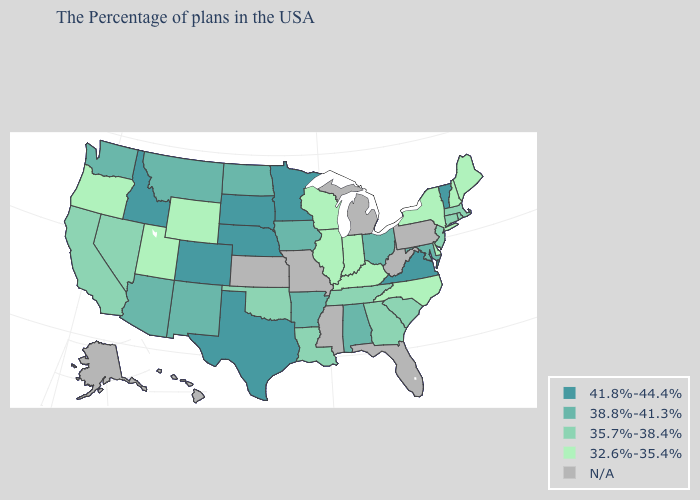What is the value of Mississippi?
Short answer required. N/A. Name the states that have a value in the range 32.6%-35.4%?
Concise answer only. Maine, New Hampshire, New York, Delaware, North Carolina, Kentucky, Indiana, Wisconsin, Illinois, Wyoming, Utah, Oregon. Which states have the highest value in the USA?
Keep it brief. Vermont, Virginia, Minnesota, Nebraska, Texas, South Dakota, Colorado, Idaho. Name the states that have a value in the range N/A?
Give a very brief answer. Pennsylvania, West Virginia, Florida, Michigan, Mississippi, Missouri, Kansas, Alaska, Hawaii. What is the value of Montana?
Quick response, please. 38.8%-41.3%. What is the lowest value in the USA?
Give a very brief answer. 32.6%-35.4%. Name the states that have a value in the range 35.7%-38.4%?
Quick response, please. Massachusetts, Rhode Island, Connecticut, New Jersey, South Carolina, Georgia, Tennessee, Louisiana, Oklahoma, Nevada, California. Name the states that have a value in the range 41.8%-44.4%?
Quick response, please. Vermont, Virginia, Minnesota, Nebraska, Texas, South Dakota, Colorado, Idaho. Among the states that border Maryland , does Virginia have the lowest value?
Be succinct. No. Name the states that have a value in the range N/A?
Write a very short answer. Pennsylvania, West Virginia, Florida, Michigan, Mississippi, Missouri, Kansas, Alaska, Hawaii. What is the value of Missouri?
Answer briefly. N/A. Does Vermont have the highest value in the USA?
Give a very brief answer. Yes. Name the states that have a value in the range 35.7%-38.4%?
Give a very brief answer. Massachusetts, Rhode Island, Connecticut, New Jersey, South Carolina, Georgia, Tennessee, Louisiana, Oklahoma, Nevada, California. Name the states that have a value in the range 35.7%-38.4%?
Write a very short answer. Massachusetts, Rhode Island, Connecticut, New Jersey, South Carolina, Georgia, Tennessee, Louisiana, Oklahoma, Nevada, California. Does the map have missing data?
Concise answer only. Yes. 